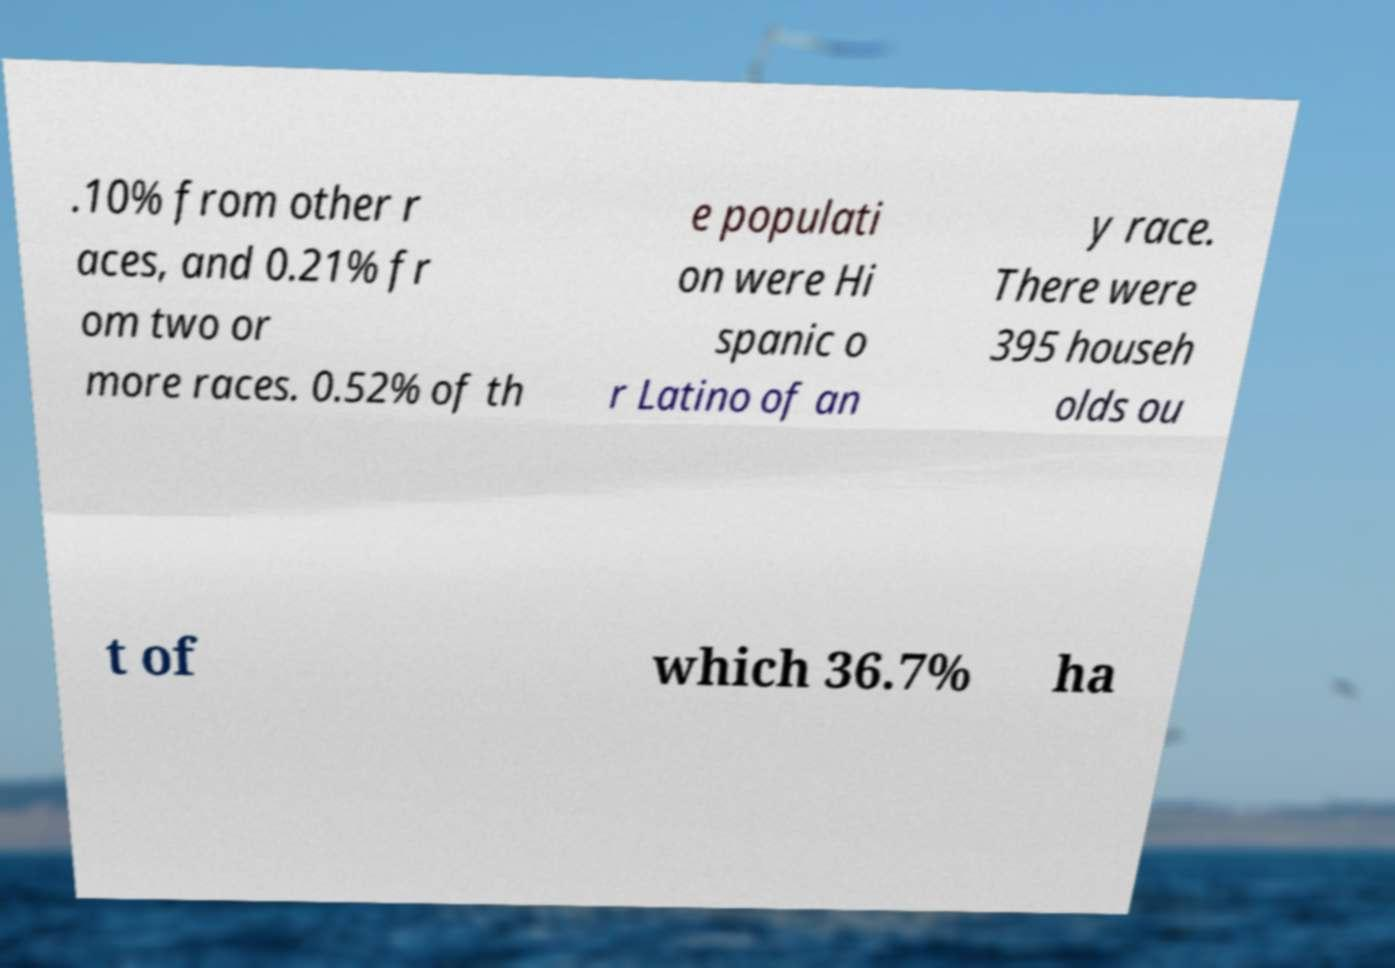Can you accurately transcribe the text from the provided image for me? .10% from other r aces, and 0.21% fr om two or more races. 0.52% of th e populati on were Hi spanic o r Latino of an y race. There were 395 househ olds ou t of which 36.7% ha 